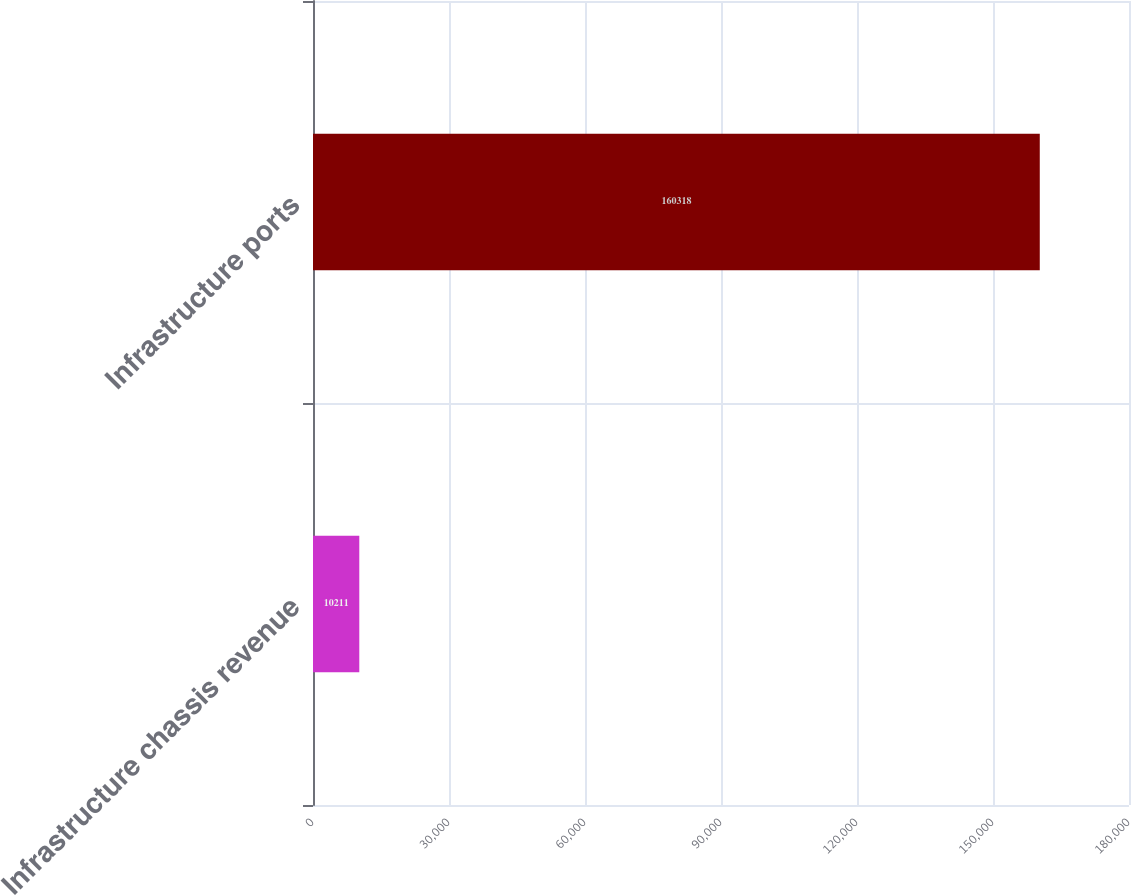Convert chart to OTSL. <chart><loc_0><loc_0><loc_500><loc_500><bar_chart><fcel>Infrastructure chassis revenue<fcel>Infrastructure ports<nl><fcel>10211<fcel>160318<nl></chart> 